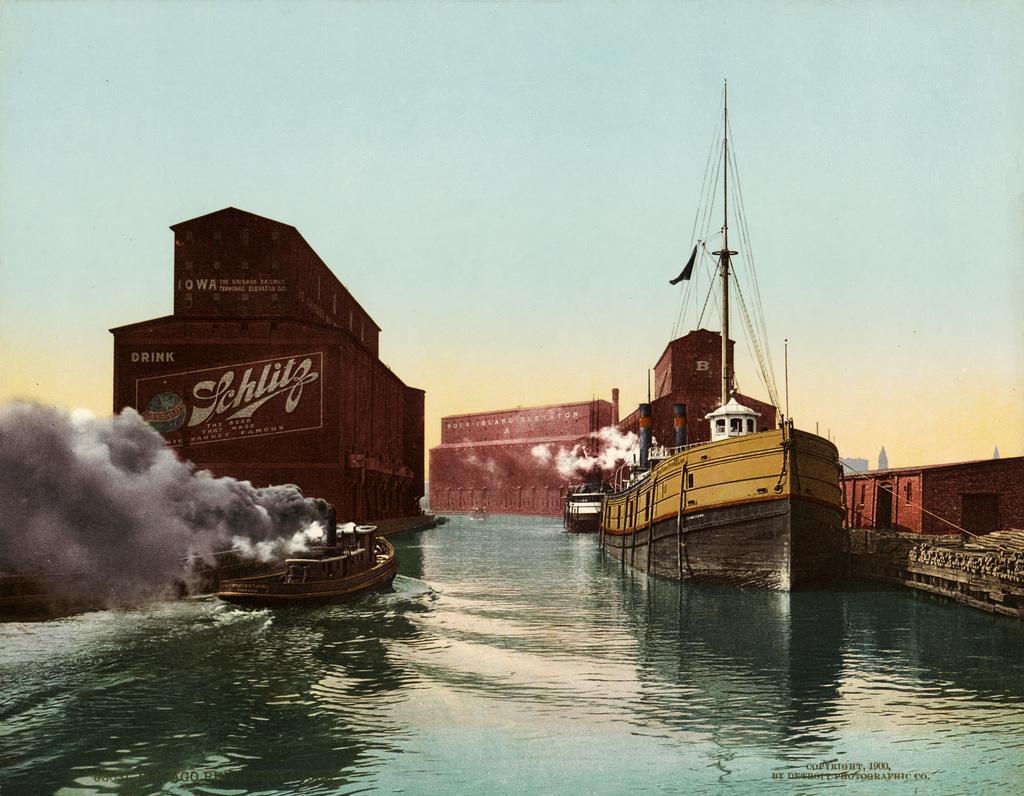Please provide a concise description of this image. This picture is clicked outside. In the center we can see the boats, ship and some other items in the water body and we can see the smoke. In the background we can see the sky and some other items. 